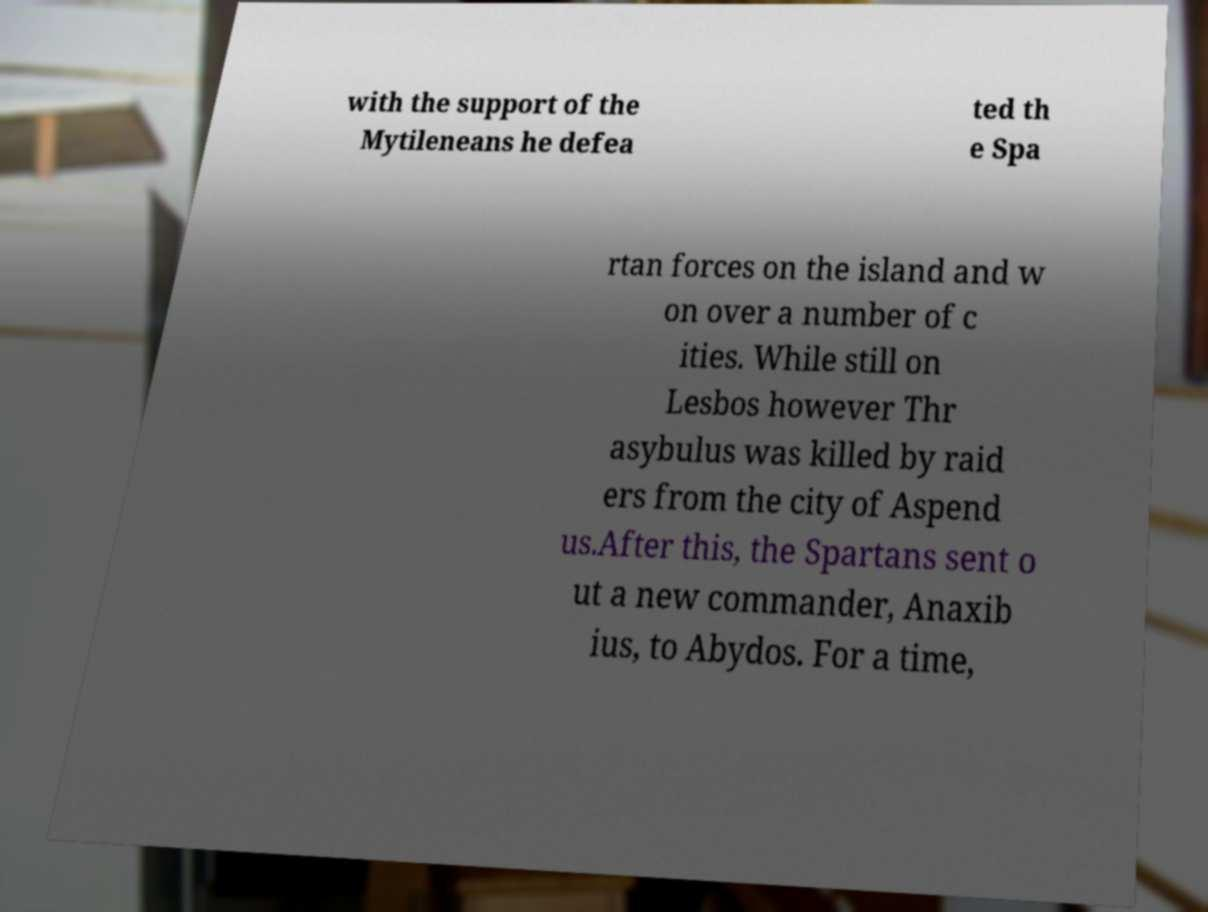Can you read and provide the text displayed in the image?This photo seems to have some interesting text. Can you extract and type it out for me? with the support of the Mytileneans he defea ted th e Spa rtan forces on the island and w on over a number of c ities. While still on Lesbos however Thr asybulus was killed by raid ers from the city of Aspend us.After this, the Spartans sent o ut a new commander, Anaxib ius, to Abydos. For a time, 